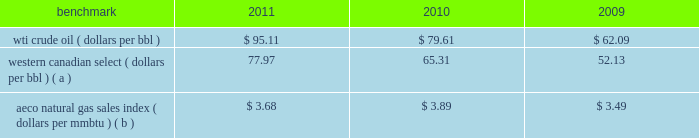A significant portion of our natural gas production in the lower 48 states of the u.s .
Is sold at bid-week prices or first-of-month indices relative to our specific producing areas .
Average settlement date henry hub natural gas prices have been relatively stable for the periods of this report ; however , a decline began in september 2011 which has continued in 2012 with february averaging $ 2.68 per mmbtu .
Should u.s .
Natural gas prices remain depressed , an impairment charge related to our natural gas assets may be necessary .
Our other major natural gas-producing regions are europe and eg .
Natural gas prices in europe have been significantly higher than in the u.s .
In the case of eg our natural gas sales are subject to term contracts , making realized prices less volatile .
The natural gas sales from eg are at fixed prices ; therefore , our worldwide reported average natural gas realized prices may not fully track market price movements .
Oil sands mining osm segment revenues correlate with prevailing market prices for the various qualities of synthetic crude oil we produce .
Roughly two-thirds of the normal output mix will track movements in wti and one-third will track movements in the canadian heavy sour crude oil marker , primarily western canadian select .
Output mix can be impacted by operational problems or planned unit outages at the mines or the upgrader .
The operating cost structure of the oil sands mining operations is predominantly fixed and therefore many of the costs incurred in times of full operation continue during production downtime .
Per-unit costs are sensitive to production rates .
Key variable costs are natural gas and diesel fuel , which track commodity markets such as the canadian alberta energy company ( 201caeco 201d ) natural gas sales index and crude oil prices , respectively .
Recently aeco prices have declined , much as henry hub prices have .
We would expect a significant , continued declined in natural gas prices to have a favorable impact on osm operating costs .
The table below shows average benchmark prices that impact both our revenues and variable costs. .
Wti crude oil ( dollars per bbl ) $ 95.11 $ 79.61 $ 62.09 western canadian select ( dollars per bbl ) ( a ) 77.97 65.31 52.13 aeco natural gas sales index ( dollars per mmbtu ) ( b ) $ 3.68 $ 3.89 $ 3.49 ( a ) monthly pricing based upon average wti adjusted for differentials unique to western canada .
( b ) monthly average day ahead index .
Integrated gas our integrated gas operations include production and marketing of products manufactured from natural gas , such as lng and methanol , in eg .
World lng trade in 2011 has been estimated to be 241 mmt .
Long-term , lng continues to be in demand as markets seek the benefits of clean burning natural gas .
Market prices for lng are not reported or posted .
In general , lng delivered to the u.s .
Is tied to henry hub prices and will track with changes in u.s .
Natural gas prices , while lng sold in europe and asia is indexed to crude oil prices and will track the movement of those prices .
We have a 60 percent ownership in an lng production facility in equatorial guinea , which sells lng under a long-term contract at prices tied to henry hub natural gas prices .
Gross sales from the plant were 4.1 mmt , 3.7 mmt and 3.9 mmt in 2011 , 2010 and 2009 .
We own a 45 percent interest in a methanol plant located in equatorial guinea through our investment in ampco .
Gross sales of methanol from the plant totaled 1039657 , 850605 and 960374 metric tonnes in 2011 , 2010 and 2009 .
Methanol demand has a direct impact on ampco 2019s earnings .
Because global demand for methanol is rather limited , changes in the supply-demand balance can have a significant impact on sales prices .
World demand for methanol in 2011 has been estimated to be 55.4 mmt .
Our plant capacity of 1.1 mmt is about 2 percent of total demand .
Operating and financial highlights significant operating and financial highlights during 2011 include : 2022 completed the spin-off of our downstream business on june 30 , 2011 2022 acquired a significant operated position in the eagle ford shale play in south texas 2022 added net proved reserves , for the e&p and osm segments combined , of 307 mmboe , excluding dispositions , for a 212 percent reserve replacement ratio .
How much has the western canadian select dollars per bbl increased since 2009? 
Computations: ((77.97 - 52.13) / 52.13)
Answer: 0.49568. 